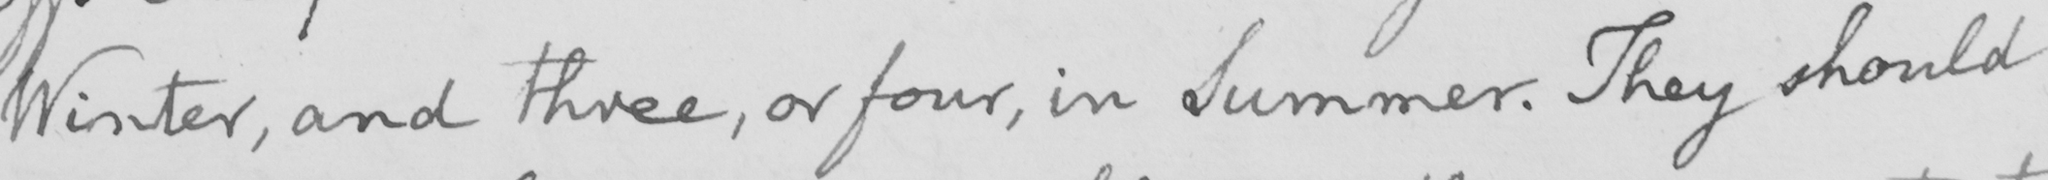Please provide the text content of this handwritten line. Winter , and three , or four , in Summer . They should 